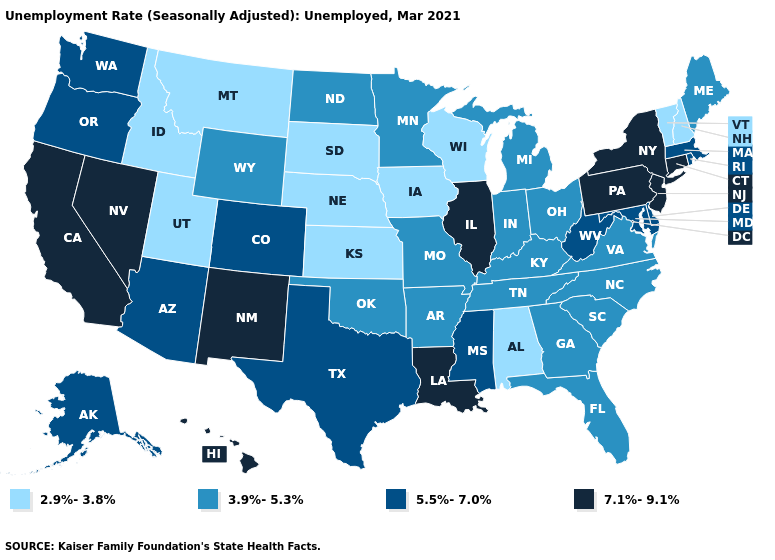Does Maine have the highest value in the USA?
Concise answer only. No. What is the lowest value in states that border Massachusetts?
Answer briefly. 2.9%-3.8%. Does Delaware have the highest value in the USA?
Concise answer only. No. Does California have the highest value in the USA?
Concise answer only. Yes. Does the map have missing data?
Concise answer only. No. Among the states that border Colorado , does Arizona have the lowest value?
Concise answer only. No. Which states have the lowest value in the USA?
Quick response, please. Alabama, Idaho, Iowa, Kansas, Montana, Nebraska, New Hampshire, South Dakota, Utah, Vermont, Wisconsin. What is the highest value in the Northeast ?
Quick response, please. 7.1%-9.1%. What is the highest value in the USA?
Answer briefly. 7.1%-9.1%. Which states have the lowest value in the USA?
Be succinct. Alabama, Idaho, Iowa, Kansas, Montana, Nebraska, New Hampshire, South Dakota, Utah, Vermont, Wisconsin. Name the states that have a value in the range 7.1%-9.1%?
Concise answer only. California, Connecticut, Hawaii, Illinois, Louisiana, Nevada, New Jersey, New Mexico, New York, Pennsylvania. Does Rhode Island have the same value as Nebraska?
Concise answer only. No. Name the states that have a value in the range 5.5%-7.0%?
Give a very brief answer. Alaska, Arizona, Colorado, Delaware, Maryland, Massachusetts, Mississippi, Oregon, Rhode Island, Texas, Washington, West Virginia. What is the highest value in the Northeast ?
Be succinct. 7.1%-9.1%. What is the value of Delaware?
Be succinct. 5.5%-7.0%. 